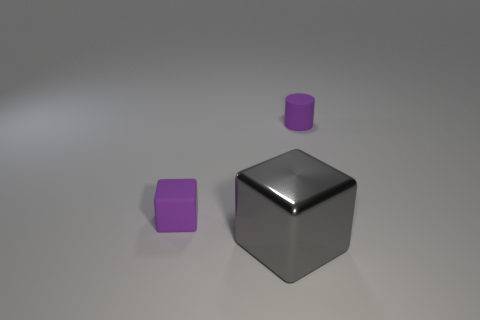What color is the block that is the same material as the small cylinder?
Offer a terse response. Purple. How many shiny objects are either big green blocks or tiny cubes?
Your answer should be very brief. 0. The rubber object that is the same size as the purple cylinder is what shape?
Ensure brevity in your answer.  Cube. What number of things are purple things on the left side of the big thing or purple things to the left of the metal cube?
Make the answer very short. 1. What material is the purple object that is the same size as the rubber cylinder?
Make the answer very short. Rubber. How many other objects are the same material as the gray block?
Your answer should be very brief. 0. Are there the same number of shiny cubes on the left side of the tiny rubber cylinder and gray metal things to the right of the gray metallic object?
Offer a very short reply. No. How many gray things are large things or small blocks?
Ensure brevity in your answer.  1. Is the color of the shiny block the same as the small thing to the left of the large gray thing?
Your answer should be compact. No. How many other objects are there of the same color as the matte block?
Your response must be concise. 1. 